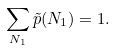<formula> <loc_0><loc_0><loc_500><loc_500>\sum _ { N _ { 1 } } \tilde { p } ( N _ { 1 } ) = 1 .</formula> 